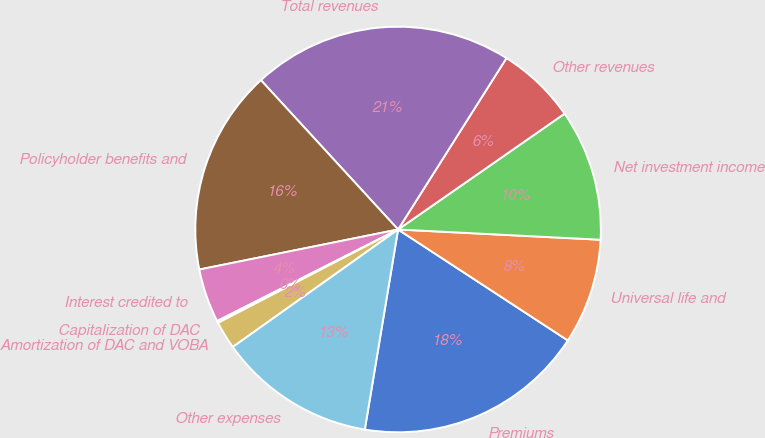<chart> <loc_0><loc_0><loc_500><loc_500><pie_chart><fcel>Premiums<fcel>Universal life and<fcel>Net investment income<fcel>Other revenues<fcel>Total revenues<fcel>Policyholder benefits and<fcel>Interest credited to<fcel>Capitalization of DAC<fcel>Amortization of DAC and VOBA<fcel>Other expenses<nl><fcel>18.41%<fcel>8.41%<fcel>10.48%<fcel>6.35%<fcel>20.8%<fcel>16.34%<fcel>4.29%<fcel>0.16%<fcel>2.22%<fcel>12.54%<nl></chart> 